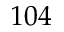<formula> <loc_0><loc_0><loc_500><loc_500>1 0 4</formula> 